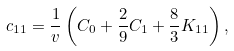Convert formula to latex. <formula><loc_0><loc_0><loc_500><loc_500>c _ { 1 1 } = \frac { 1 } { v } \left ( C _ { 0 } + { \frac { 2 } { 9 } } C _ { 1 } + { \frac { 8 } { 3 } } K _ { 1 1 } \right ) ,</formula> 